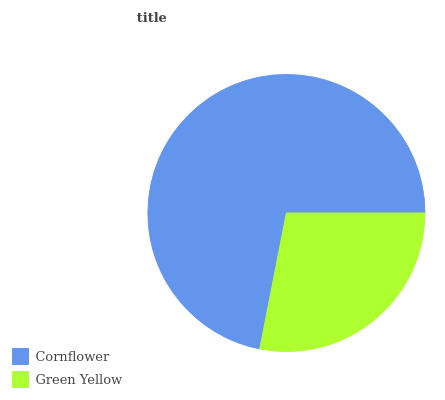Is Green Yellow the minimum?
Answer yes or no. Yes. Is Cornflower the maximum?
Answer yes or no. Yes. Is Green Yellow the maximum?
Answer yes or no. No. Is Cornflower greater than Green Yellow?
Answer yes or no. Yes. Is Green Yellow less than Cornflower?
Answer yes or no. Yes. Is Green Yellow greater than Cornflower?
Answer yes or no. No. Is Cornflower less than Green Yellow?
Answer yes or no. No. Is Cornflower the high median?
Answer yes or no. Yes. Is Green Yellow the low median?
Answer yes or no. Yes. Is Green Yellow the high median?
Answer yes or no. No. Is Cornflower the low median?
Answer yes or no. No. 